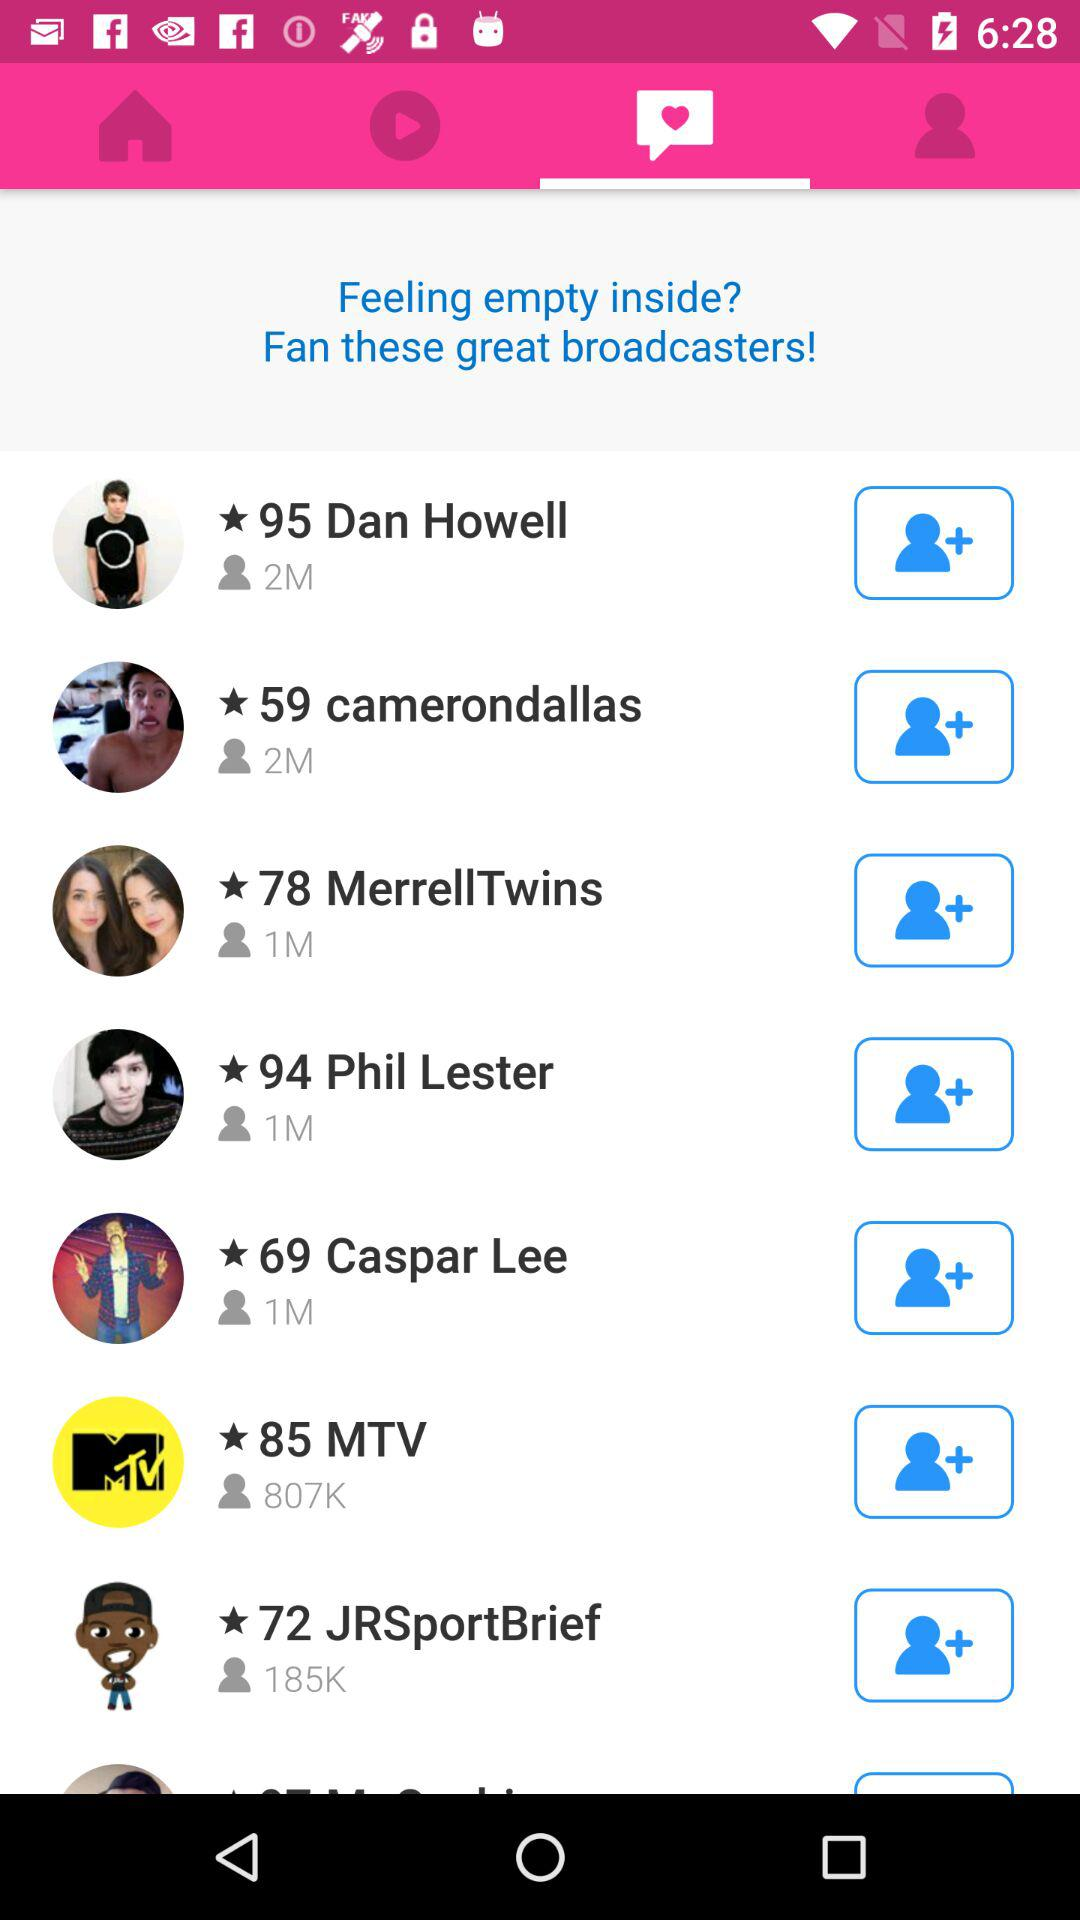Which tab is opened?
When the provided information is insufficient, respond with <no answer>. <no answer> 